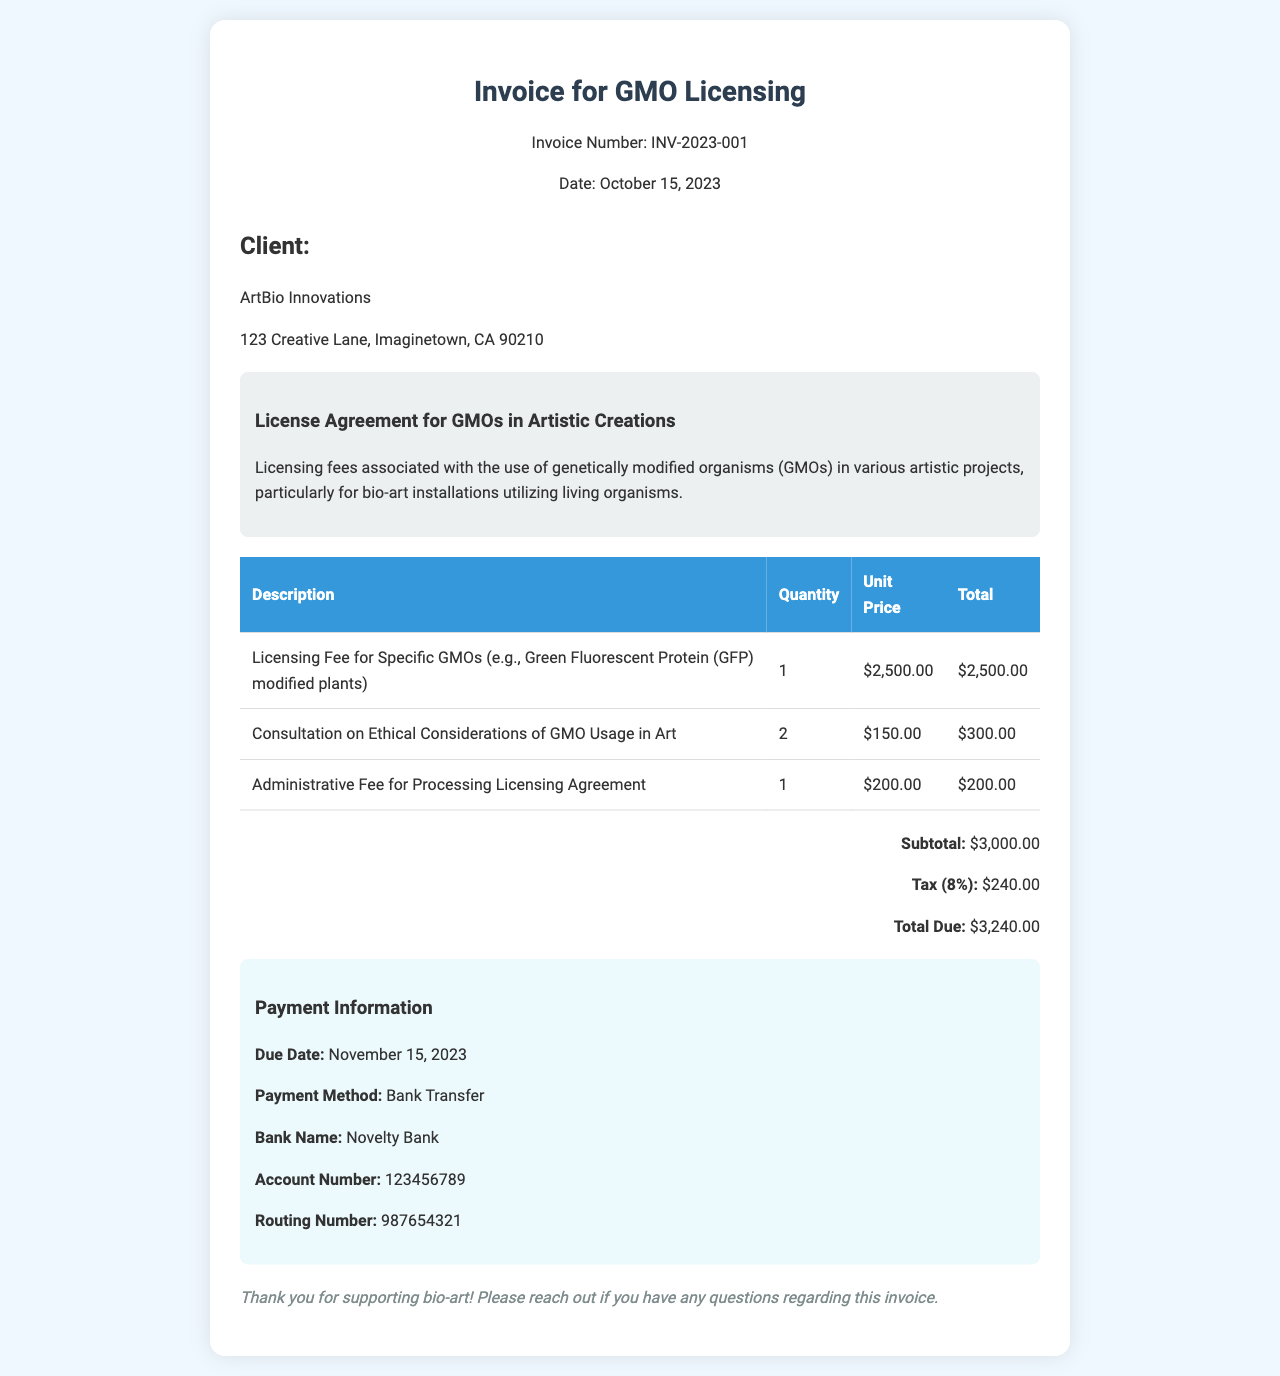what is the invoice number? The invoice number is specifically stated in the header of the document as INV-2023-001.
Answer: INV-2023-001 what is the due date for payment? The due date for payment is outlined in the payment information section of the invoice.
Answer: November 15, 2023 how many Consultation on Ethical Considerations of GMO Usage in Art were charged? The document specifies that 2 consultations were charged under the listed services.
Answer: 2 what is the subtotal amount before tax? The subtotal is detailed in the totals section of the invoice as the sum of the service fees before tax.
Answer: $3,000.00 what is the total due amount including tax? The total due is calculated and mentioned in the totals section of the invoice as the amount to be paid after including the tax.
Answer: $3,240.00 who is the client mentioned in the invoice? The client information is presented in the client info section, clearly naming the organization.
Answer: ArtBio Innovations what specific GMO is mentioned in the licensing fee? The specificity of the GMO is described in the licensing fee line item in the table of services provided.
Answer: Green Fluorescent Protein (GFP) modified plants what is the administrative fee for processing the licensing agreement? The invoice details the fee charged for processing in the service list.
Answer: $200.00 